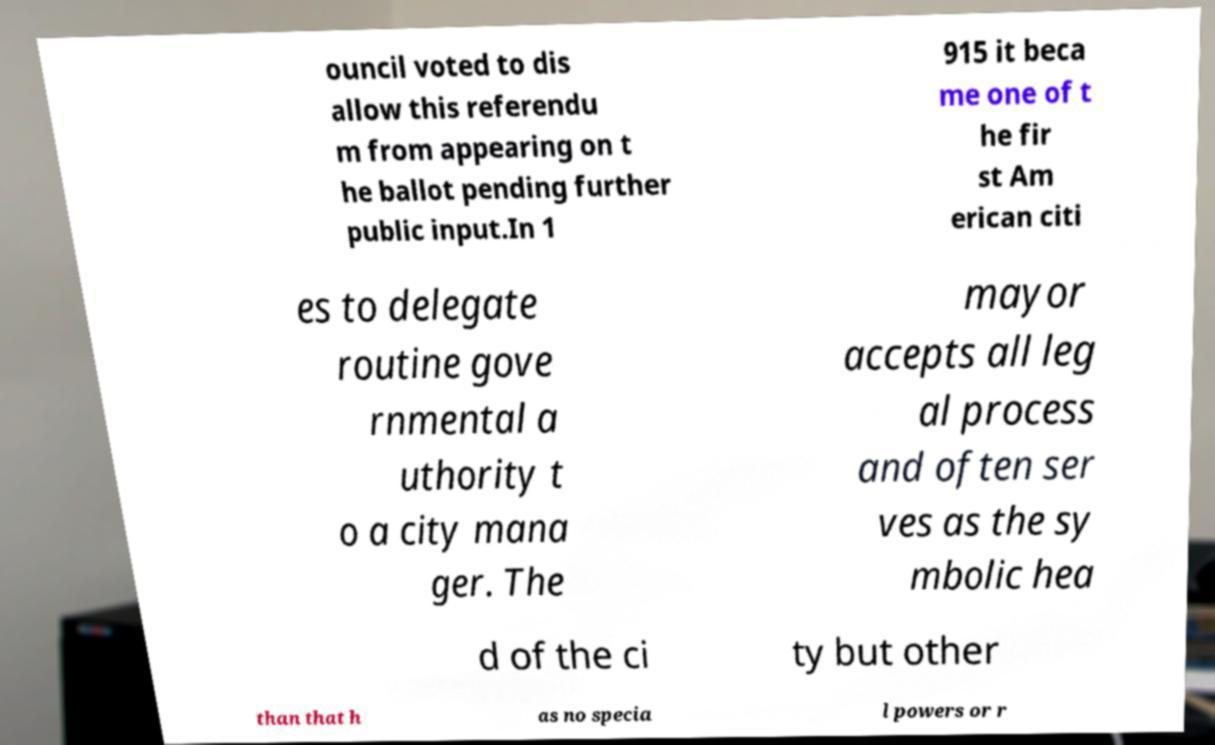For documentation purposes, I need the text within this image transcribed. Could you provide that? ouncil voted to dis allow this referendu m from appearing on t he ballot pending further public input.In 1 915 it beca me one of t he fir st Am erican citi es to delegate routine gove rnmental a uthority t o a city mana ger. The mayor accepts all leg al process and often ser ves as the sy mbolic hea d of the ci ty but other than that h as no specia l powers or r 